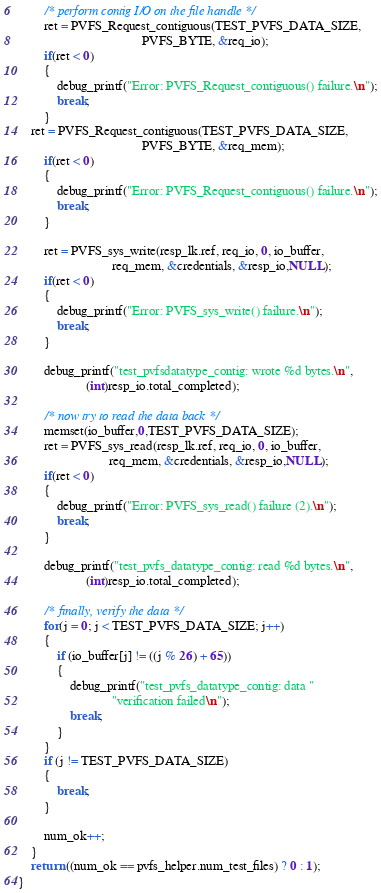Convert code to text. <code><loc_0><loc_0><loc_500><loc_500><_C_>
        /* perform contig I/O on the file handle */
        ret = PVFS_Request_contiguous(TEST_PVFS_DATA_SIZE,
                                      PVFS_BYTE, &req_io);
        if(ret < 0)
        {
            debug_printf("Error: PVFS_Request_contiguous() failure.\n");
            break;
        }
	ret = PVFS_Request_contiguous(TEST_PVFS_DATA_SIZE,
                                      PVFS_BYTE, &req_mem);
        if(ret < 0)
        {
            debug_printf("Error: PVFS_Request_contiguous() failure.\n");
            break;
        }

        ret = PVFS_sys_write(resp_lk.ref, req_io, 0, io_buffer,
                             req_mem, &credentials, &resp_io,NULL);
        if(ret < 0)
        {
            debug_printf("Error: PVFS_sys_write() failure.\n");
            break;
        }

        debug_printf("test_pvfsdatatype_contig: wrote %d bytes.\n",
                     (int)resp_io.total_completed);

        /* now try to read the data back */
        memset(io_buffer,0,TEST_PVFS_DATA_SIZE);
        ret = PVFS_sys_read(resp_lk.ref, req_io, 0, io_buffer,
                            req_mem, &credentials, &resp_io,NULL);
        if(ret < 0)
        {
            debug_printf("Error: PVFS_sys_read() failure (2).\n");
            break;
        }

        debug_printf("test_pvfs_datatype_contig: read %d bytes.\n",
                     (int)resp_io.total_completed);

        /* finally, verify the data */
        for(j = 0; j < TEST_PVFS_DATA_SIZE; j++)
        {
            if (io_buffer[j] != ((j % 26) + 65))
            {
                debug_printf("test_pvfs_datatype_contig: data "
                             "verification failed\n");
                break;
            }
        }
        if (j != TEST_PVFS_DATA_SIZE)
        {
            break;
        }

        num_ok++;
    }
    return ((num_ok == pvfs_helper.num_test_files) ? 0 : 1);
}
</code> 